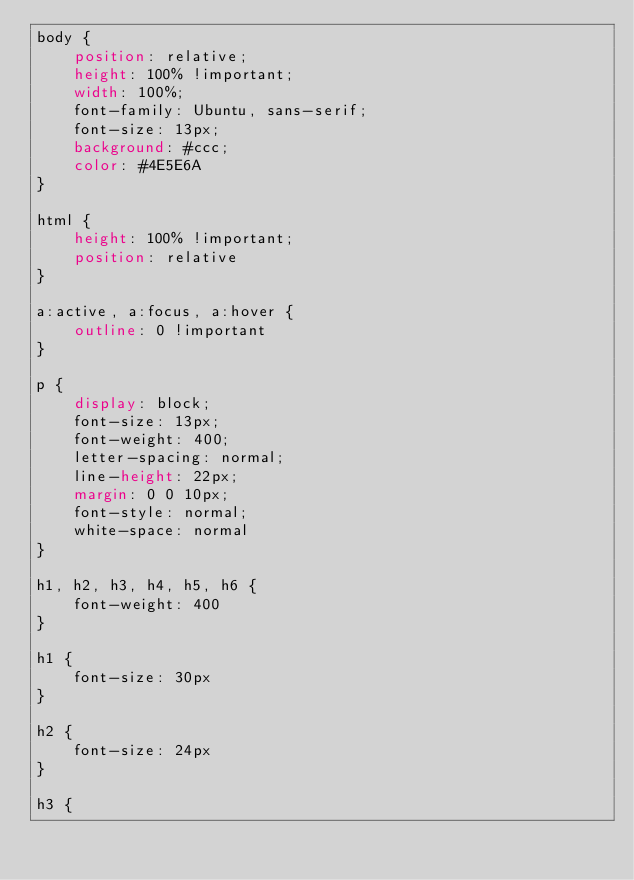Convert code to text. <code><loc_0><loc_0><loc_500><loc_500><_CSS_>body {
    position: relative;
    height: 100% !important;
    width: 100%;
    font-family: Ubuntu, sans-serif;
    font-size: 13px;
    background: #ccc;
    color: #4E5E6A
}

html {
    height: 100% !important;
    position: relative
}

a:active, a:focus, a:hover {
    outline: 0 !important
}

p {
    display: block;
    font-size: 13px;
    font-weight: 400;
    letter-spacing: normal;
    line-height: 22px;
    margin: 0 0 10px;
    font-style: normal;
    white-space: normal
}

h1, h2, h3, h4, h5, h6 {
    font-weight: 400
}

h1 {
    font-size: 30px
}

h2 {
    font-size: 24px
}

h3 {</code> 